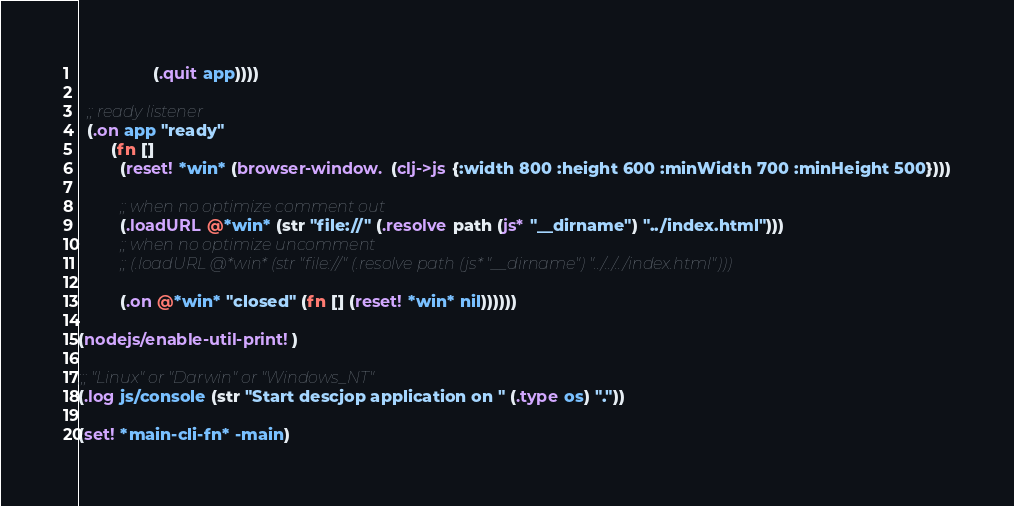Convert code to text. <code><loc_0><loc_0><loc_500><loc_500><_Clojure_>                (.quit app))))

  ;; ready listener
  (.on app "ready"
       (fn []
         (reset! *win* (browser-window. (clj->js {:width 800 :height 600 :minWidth 700 :minHeight 500})))

         ;; when no optimize comment out
         (.loadURL @*win* (str "file://" (.resolve path (js* "__dirname") "../index.html")))
         ;; when no optimize uncomment
         ;; (.loadURL @*win* (str "file://" (.resolve path (js* "__dirname") "../../../index.html")))

         (.on @*win* "closed" (fn [] (reset! *win* nil))))))

(nodejs/enable-util-print!)

;;; "Linux" or "Darwin" or "Windows_NT"
(.log js/console (str "Start descjop application on " (.type os) "."))

(set! *main-cli-fn* -main)
</code> 